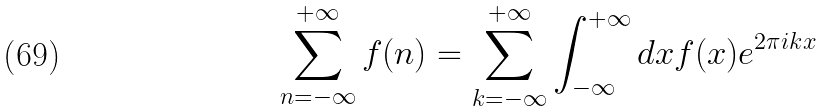<formula> <loc_0><loc_0><loc_500><loc_500>\sum _ { n = - \infty } ^ { + \infty } f ( n ) = \sum _ { k = - \infty } ^ { + \infty } \int _ { - \infty } ^ { + \infty } d x f ( x ) e ^ { 2 \pi i k x }</formula> 